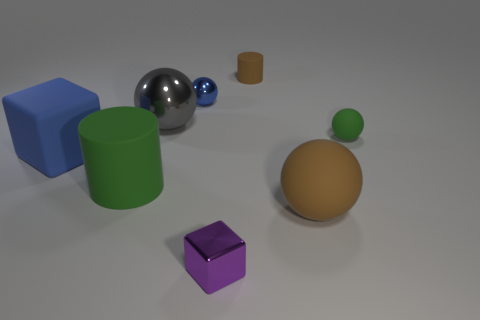Add 1 tiny yellow metallic cubes. How many objects exist? 9 Subtract all brown matte spheres. How many spheres are left? 3 Subtract 1 cylinders. How many cylinders are left? 1 Subtract all cubes. How many objects are left? 6 Subtract all gray spheres. How many spheres are left? 3 Add 2 cylinders. How many cylinders exist? 4 Subtract 1 brown balls. How many objects are left? 7 Subtract all purple cylinders. Subtract all cyan spheres. How many cylinders are left? 2 Subtract all matte things. Subtract all small purple shiny objects. How many objects are left? 2 Add 6 gray shiny spheres. How many gray shiny spheres are left? 7 